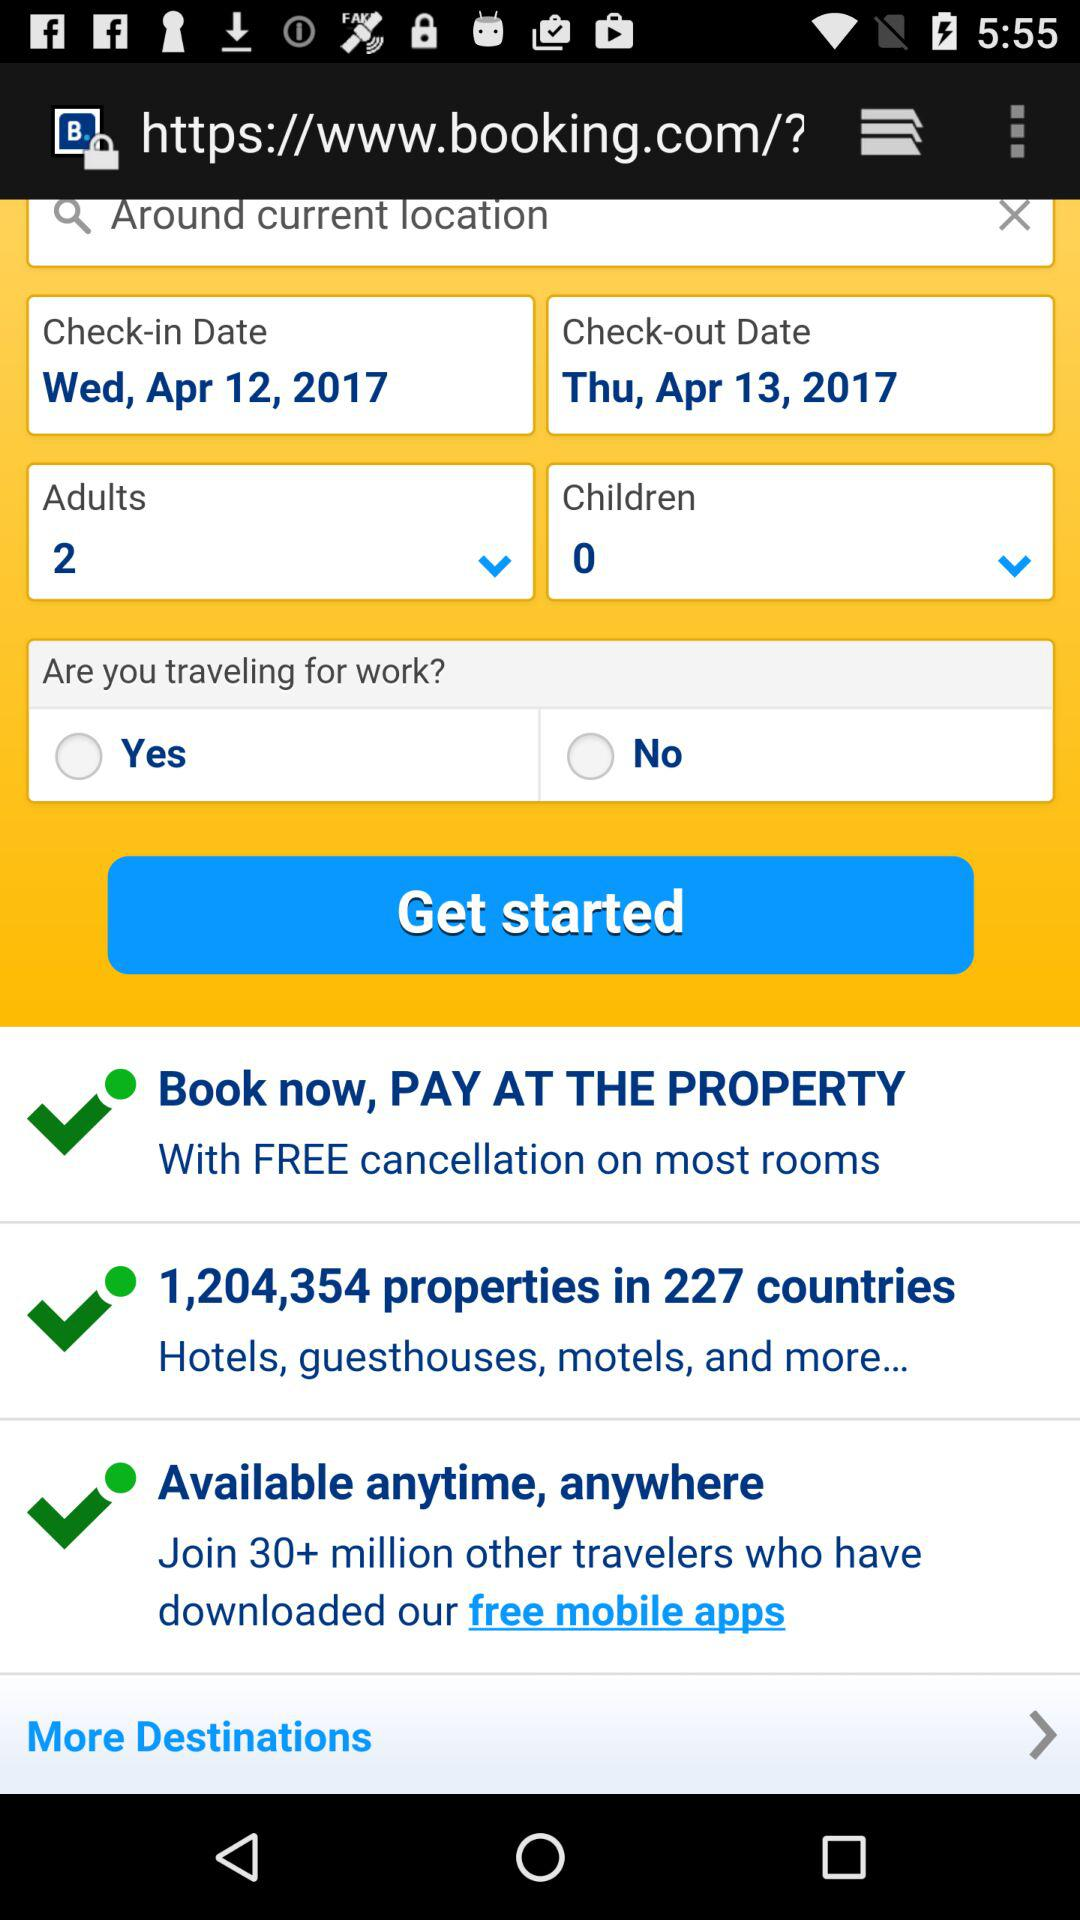Which date is selected for check-out? The selected date is Thursday, April 13, 2017. 